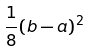<formula> <loc_0><loc_0><loc_500><loc_500>\frac { 1 } { 8 } ( b - a ) ^ { 2 }</formula> 